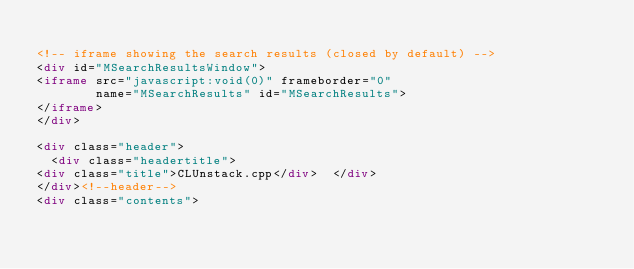<code> <loc_0><loc_0><loc_500><loc_500><_HTML_>
<!-- iframe showing the search results (closed by default) -->
<div id="MSearchResultsWindow">
<iframe src="javascript:void(0)" frameborder="0" 
        name="MSearchResults" id="MSearchResults">
</iframe>
</div>

<div class="header">
  <div class="headertitle">
<div class="title">CLUnstack.cpp</div>  </div>
</div><!--header-->
<div class="contents"></code> 